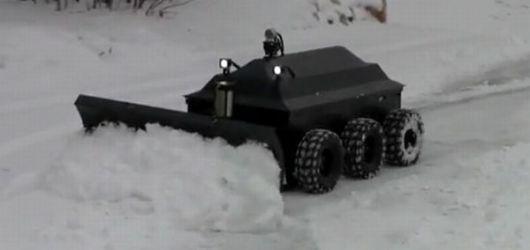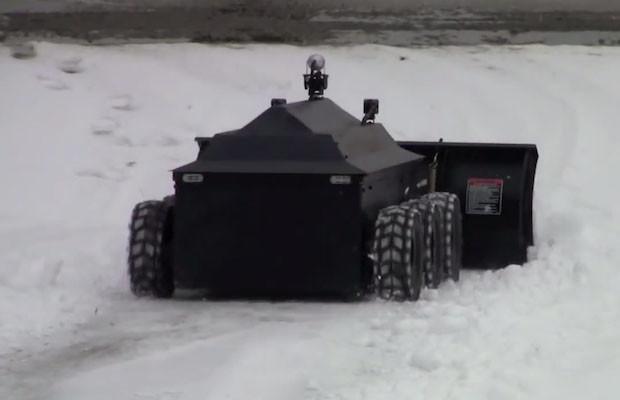The first image is the image on the left, the second image is the image on the right. For the images displayed, is the sentence "The plows in the left and right images face opposite directions, and the left image features an orange plow on a surface without snow, while the right image features a green vehicle on a snow-covered surface." factually correct? Answer yes or no. No. The first image is the image on the left, the second image is the image on the right. Considering the images on both sides, is "The left and right image contains the same number of snow vehicle with at least one green vehicle." valid? Answer yes or no. No. 